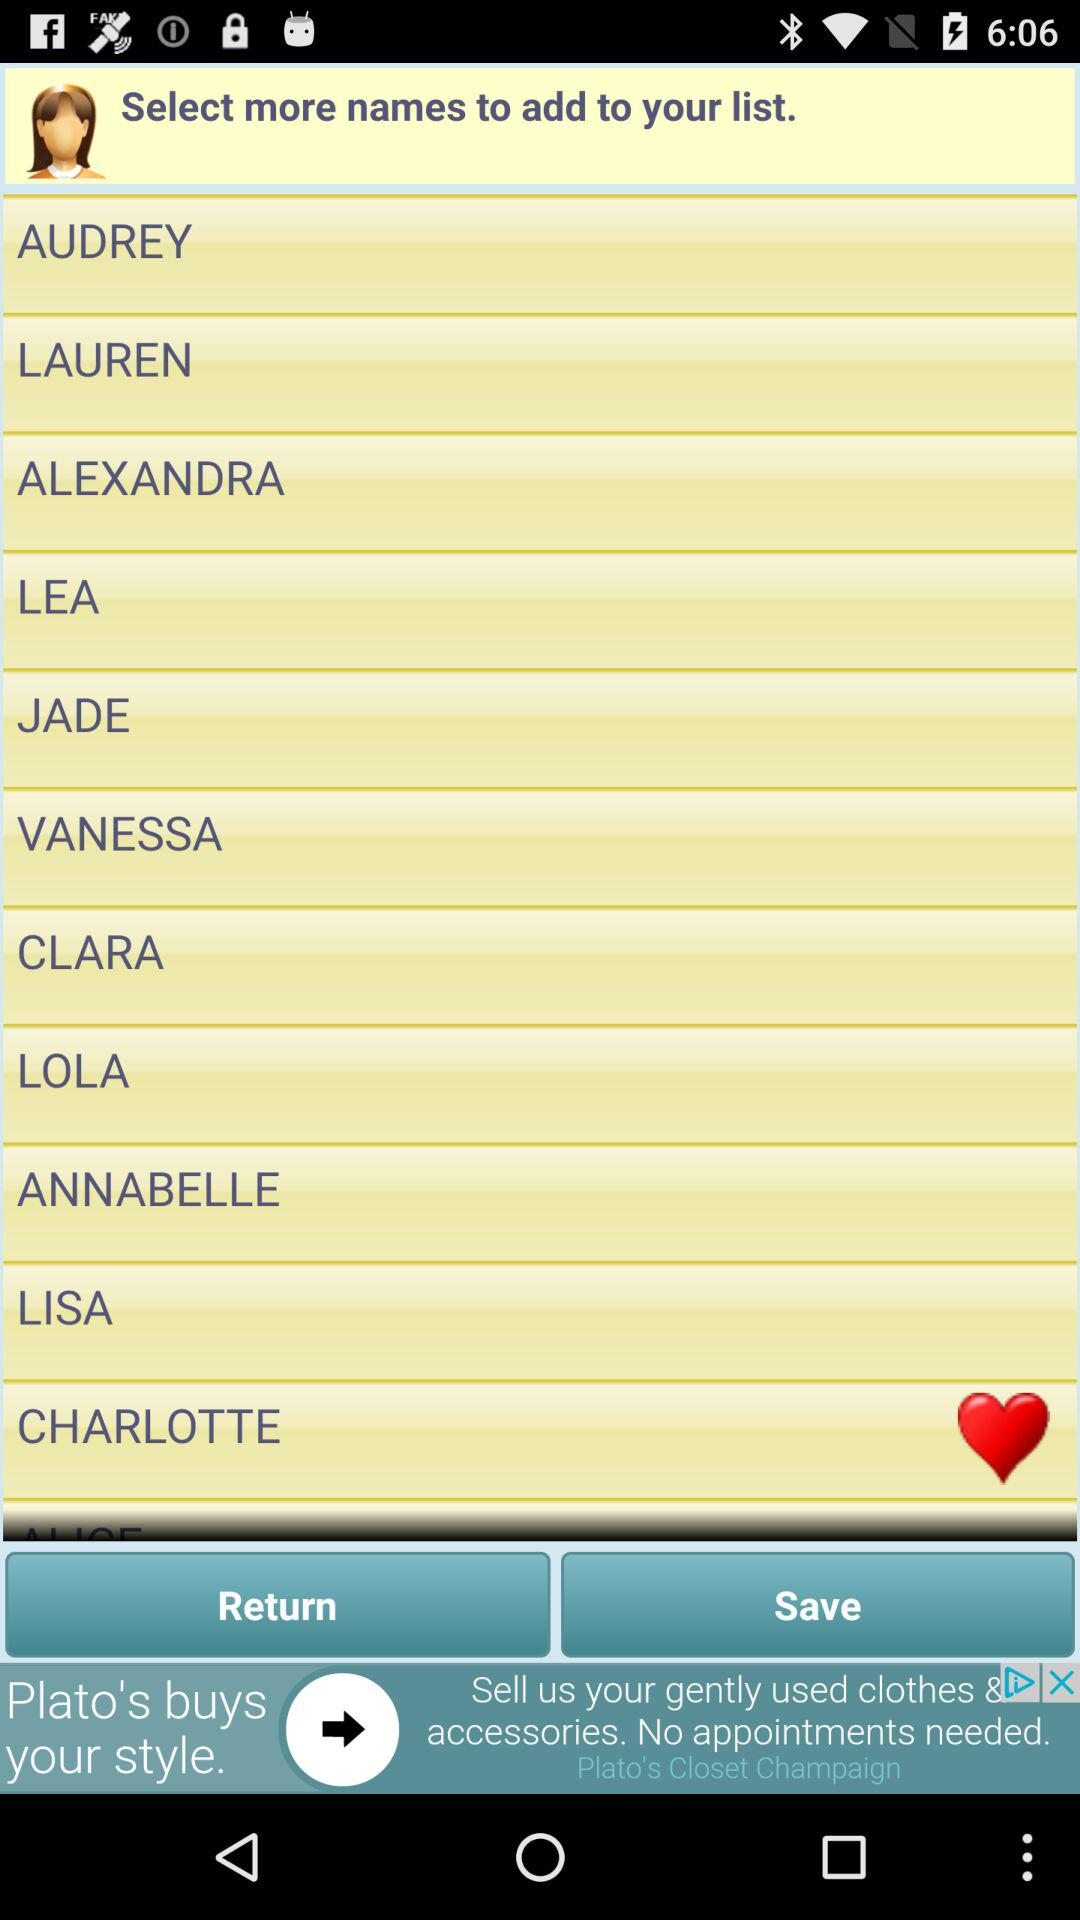What are the names on the list? The names on the list are Audrey, Lauren, Alexandra, Lea, Jade, Vanessa, Clara, Lola, Annabelle, Lisa and Charlotte. 